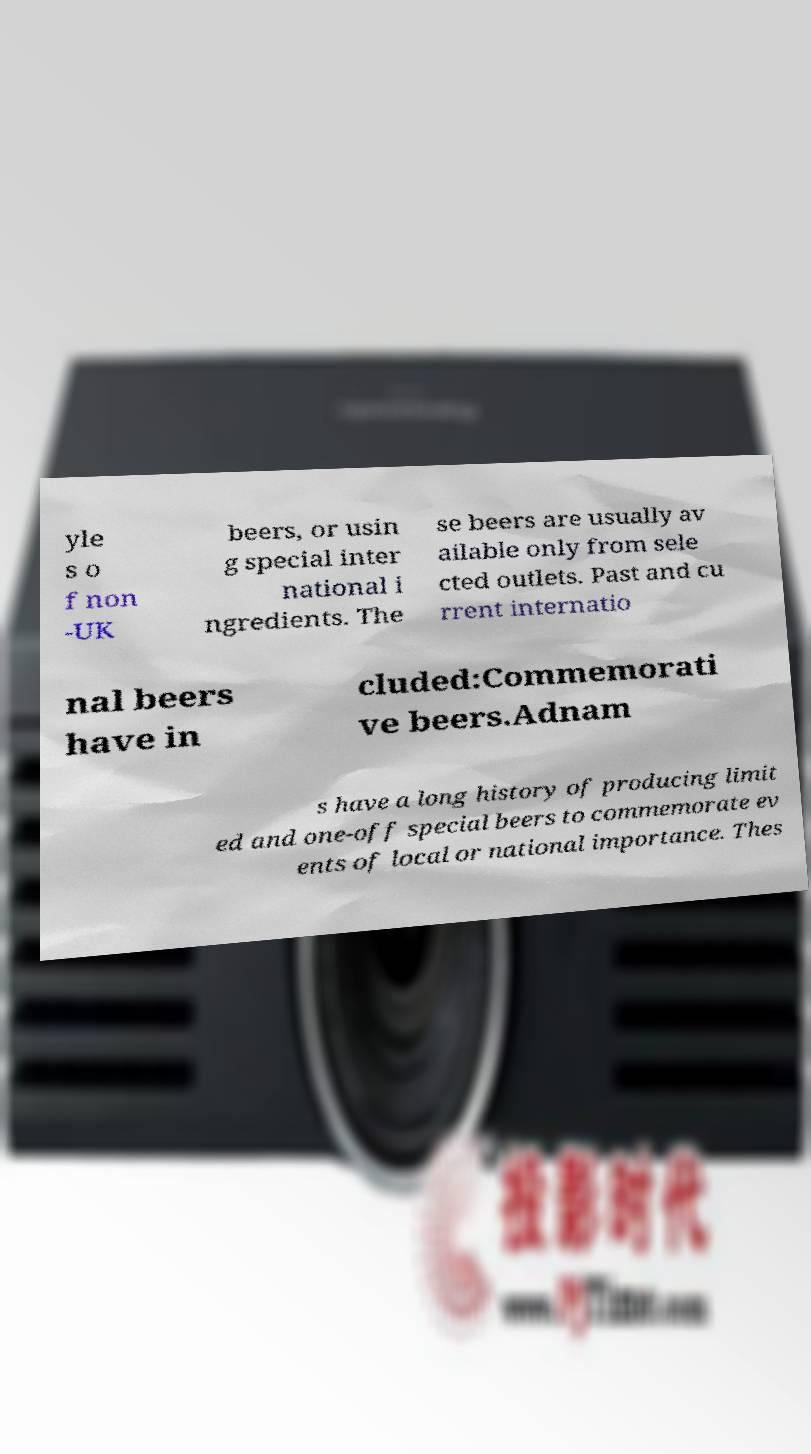Please identify and transcribe the text found in this image. yle s o f non -UK beers, or usin g special inter national i ngredients. The se beers are usually av ailable only from sele cted outlets. Past and cu rrent internatio nal beers have in cluded:Commemorati ve beers.Adnam s have a long history of producing limit ed and one-off special beers to commemorate ev ents of local or national importance. Thes 